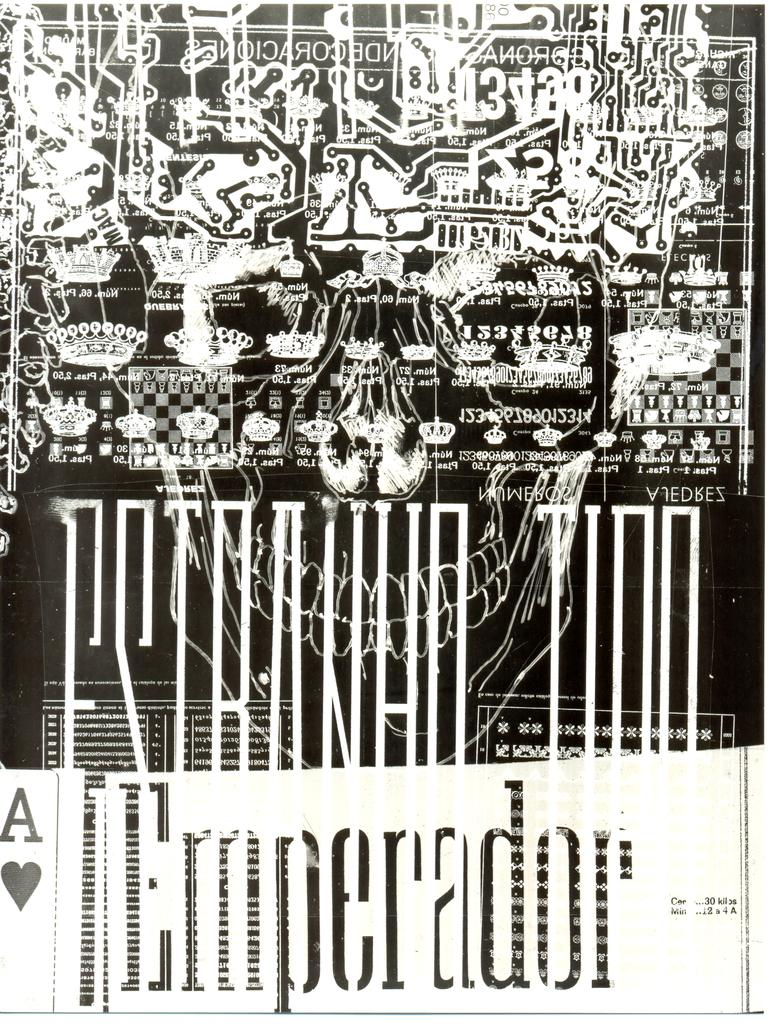<image>
Describe the image concisely. The picture has an ace of hearts in the bottom corner 